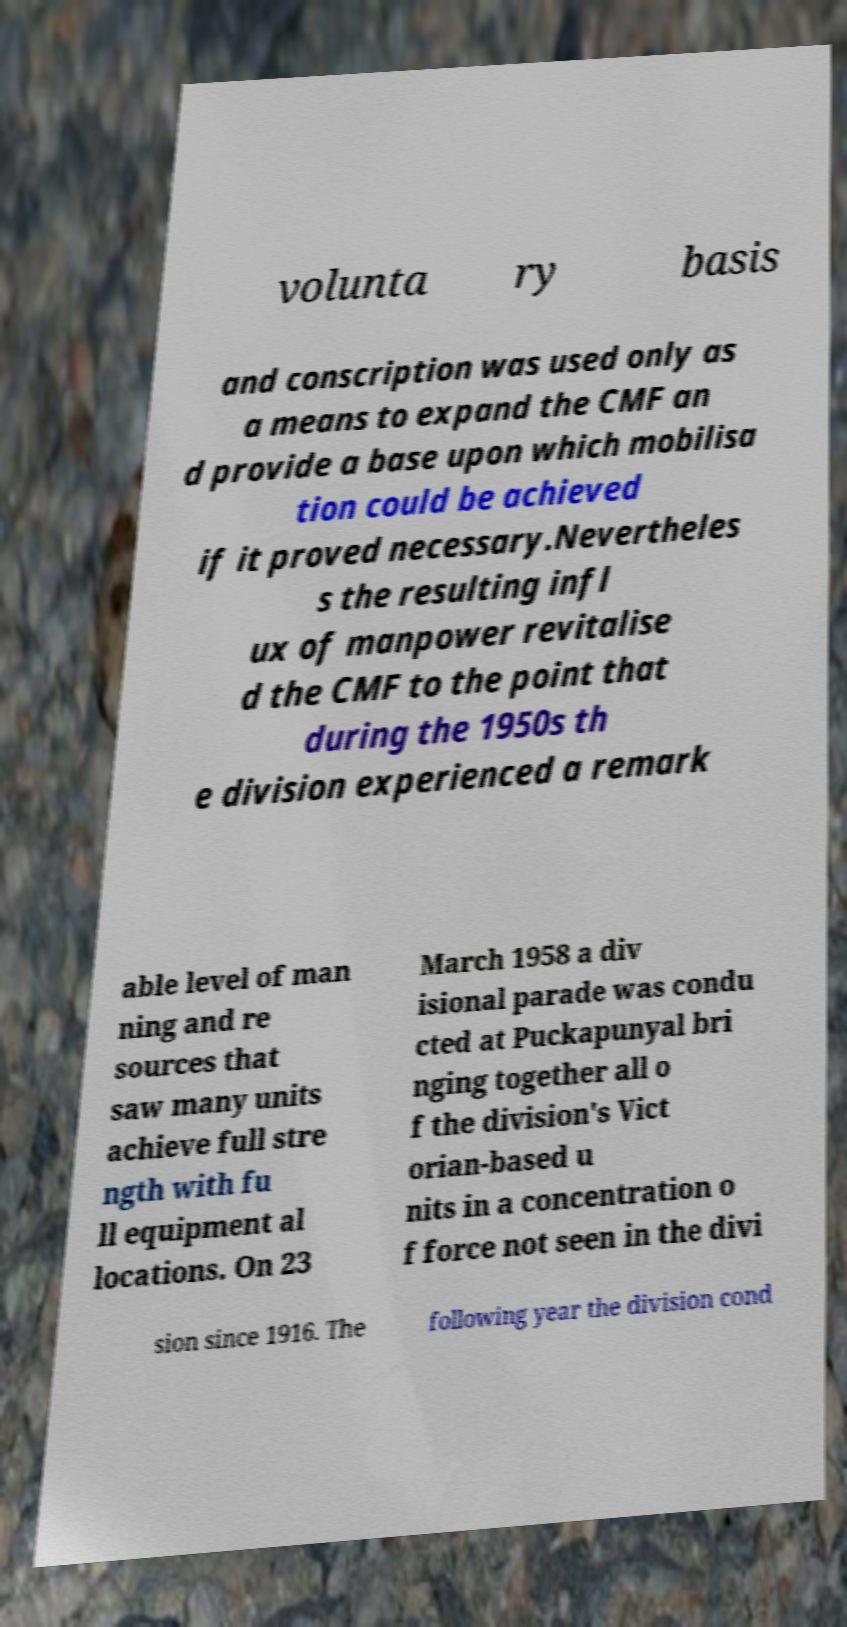For documentation purposes, I need the text within this image transcribed. Could you provide that? volunta ry basis and conscription was used only as a means to expand the CMF an d provide a base upon which mobilisa tion could be achieved if it proved necessary.Nevertheles s the resulting infl ux of manpower revitalise d the CMF to the point that during the 1950s th e division experienced a remark able level of man ning and re sources that saw many units achieve full stre ngth with fu ll equipment al locations. On 23 March 1958 a div isional parade was condu cted at Puckapunyal bri nging together all o f the division's Vict orian-based u nits in a concentration o f force not seen in the divi sion since 1916. The following year the division cond 